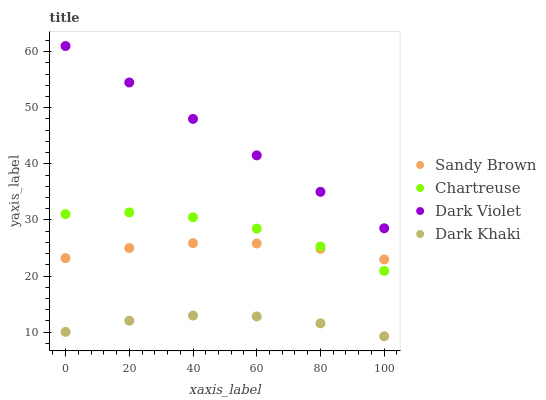Does Dark Khaki have the minimum area under the curve?
Answer yes or no. Yes. Does Dark Violet have the maximum area under the curve?
Answer yes or no. Yes. Does Chartreuse have the minimum area under the curve?
Answer yes or no. No. Does Chartreuse have the maximum area under the curve?
Answer yes or no. No. Is Dark Violet the smoothest?
Answer yes or no. Yes. Is Chartreuse the roughest?
Answer yes or no. Yes. Is Sandy Brown the smoothest?
Answer yes or no. No. Is Sandy Brown the roughest?
Answer yes or no. No. Does Dark Khaki have the lowest value?
Answer yes or no. Yes. Does Chartreuse have the lowest value?
Answer yes or no. No. Does Dark Violet have the highest value?
Answer yes or no. Yes. Does Chartreuse have the highest value?
Answer yes or no. No. Is Dark Khaki less than Dark Violet?
Answer yes or no. Yes. Is Dark Violet greater than Sandy Brown?
Answer yes or no. Yes. Does Chartreuse intersect Sandy Brown?
Answer yes or no. Yes. Is Chartreuse less than Sandy Brown?
Answer yes or no. No. Is Chartreuse greater than Sandy Brown?
Answer yes or no. No. Does Dark Khaki intersect Dark Violet?
Answer yes or no. No. 